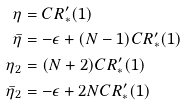<formula> <loc_0><loc_0><loc_500><loc_500>\eta & = C R _ { \ast } ^ { \prime } ( 1 ) \\ \bar { \eta } & = - \epsilon + ( N - 1 ) C R _ { \ast } ^ { \prime } ( 1 ) \\ \eta _ { 2 } & = ( N + 2 ) C R _ { \ast } ^ { \prime } ( 1 ) \\ \bar { \eta } _ { 2 } & = - \epsilon + 2 N C R _ { \ast } ^ { \prime } ( 1 )</formula> 